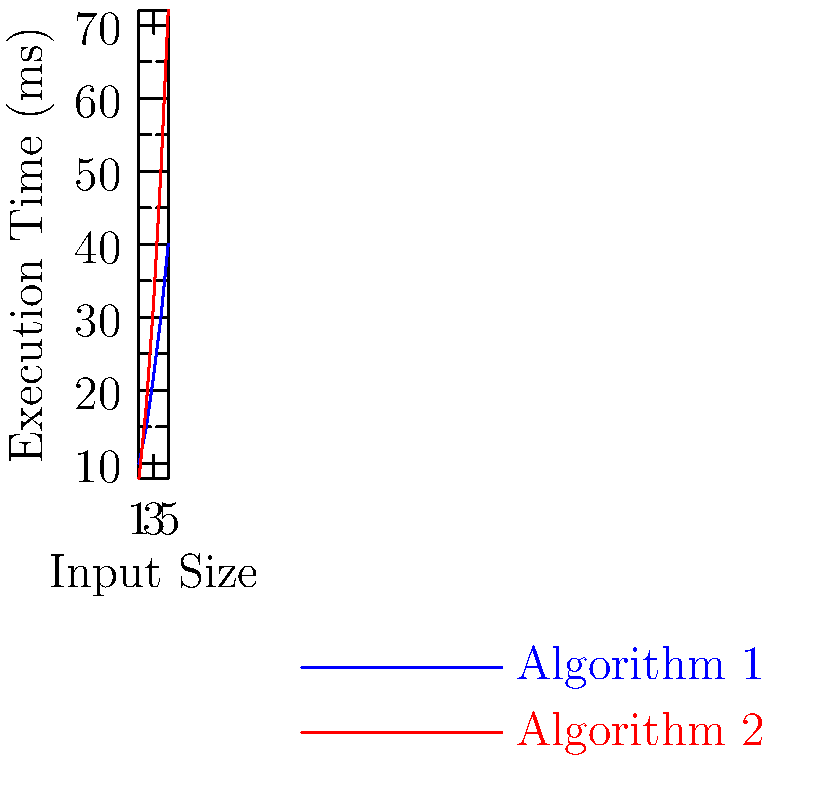As a software engineer interested in management, you're evaluating the efficiency of two coding algorithms for a critical project. The graph shows the execution time of Algorithm 1 (blue) and Algorithm 2 (red) for different input sizes. Which algorithm would you recommend to your team for large-scale data processing, and why? Express your answer in terms of the algorithms' vector representations. To determine the most efficient algorithm for large-scale data processing, we need to analyze the growth rate of execution time for each algorithm as input size increases. Let's approach this step-by-step:

1. Represent the algorithms as vectors:
   Algorithm 1: $\mathbf{a_1} = [10, 15, 22, 30, 40]$
   Algorithm 2: $\mathbf{a_2} = [8, 18, 32, 50, 72]$

2. Calculate the rate of change between consecutive elements for each algorithm:
   Algorithm 1: $[5, 7, 8, 10]$
   Algorithm 2: $[10, 14, 18, 22]$

3. Observe the pattern:
   - Algorithm 1's rate of change is increasing linearly
   - Algorithm 2's rate of change is increasing more rapidly

4. Extrapolate for larger input sizes:
   Algorithm 1 shows a linear growth rate, while Algorithm 2 exhibits quadratic growth.

5. Calculate the dot product of each algorithm vector with a unit vector $\mathbf{u} = [1, 1, 1, 1, 1]$ to get a single metric for comparison:
   $\mathbf{a_1} \cdot \mathbf{u} = 10 + 15 + 22 + 30 + 40 = 117$
   $\mathbf{a_2} \cdot \mathbf{u} = 8 + 18 + 32 + 50 + 72 = 180$

6. Compare the results:
   Algorithm 1 has a lower total execution time across all input sizes.

7. Consider the management perspective:
   For large-scale data processing, we need an algorithm that scales well with increasing input size.

Given the linear growth rate and lower overall execution time, Algorithm 1 is more suitable for large-scale data processing.
Answer: Algorithm 1, due to linear growth rate and lower $\mathbf{a} \cdot \mathbf{u}$ value. 